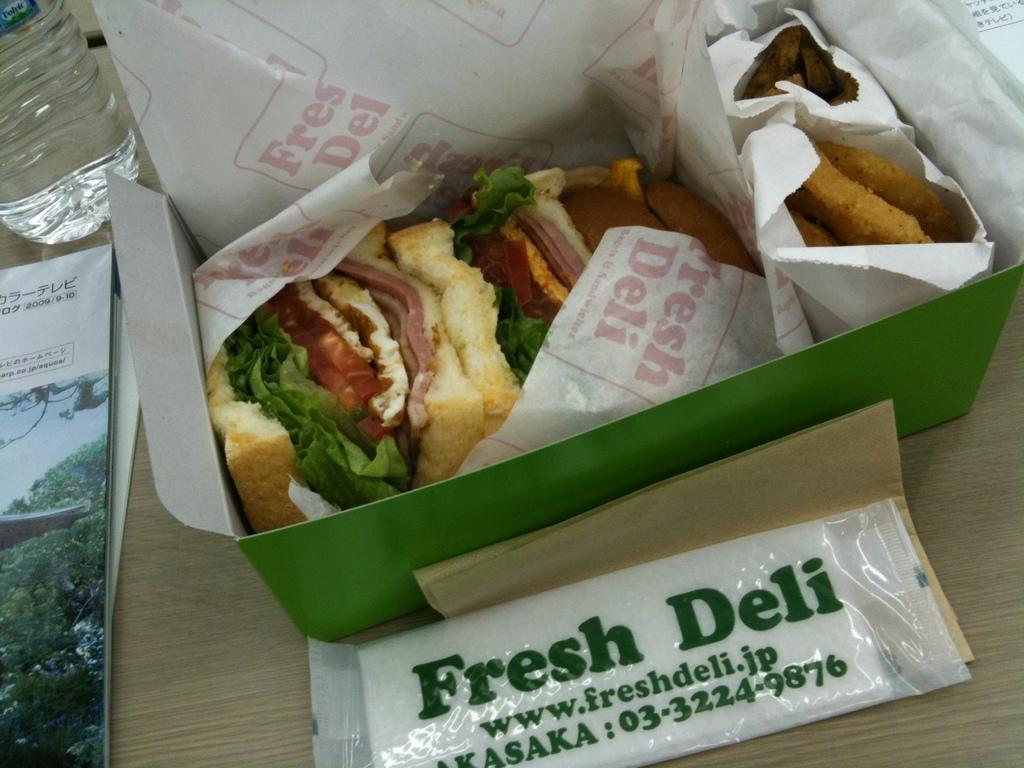How would you summarize this image in a sentence or two? In the center of the picture there are food items wrapped in a box. At the bottom there are cover and paper. On the left there are book and water. On the right there is a white cover like object. 